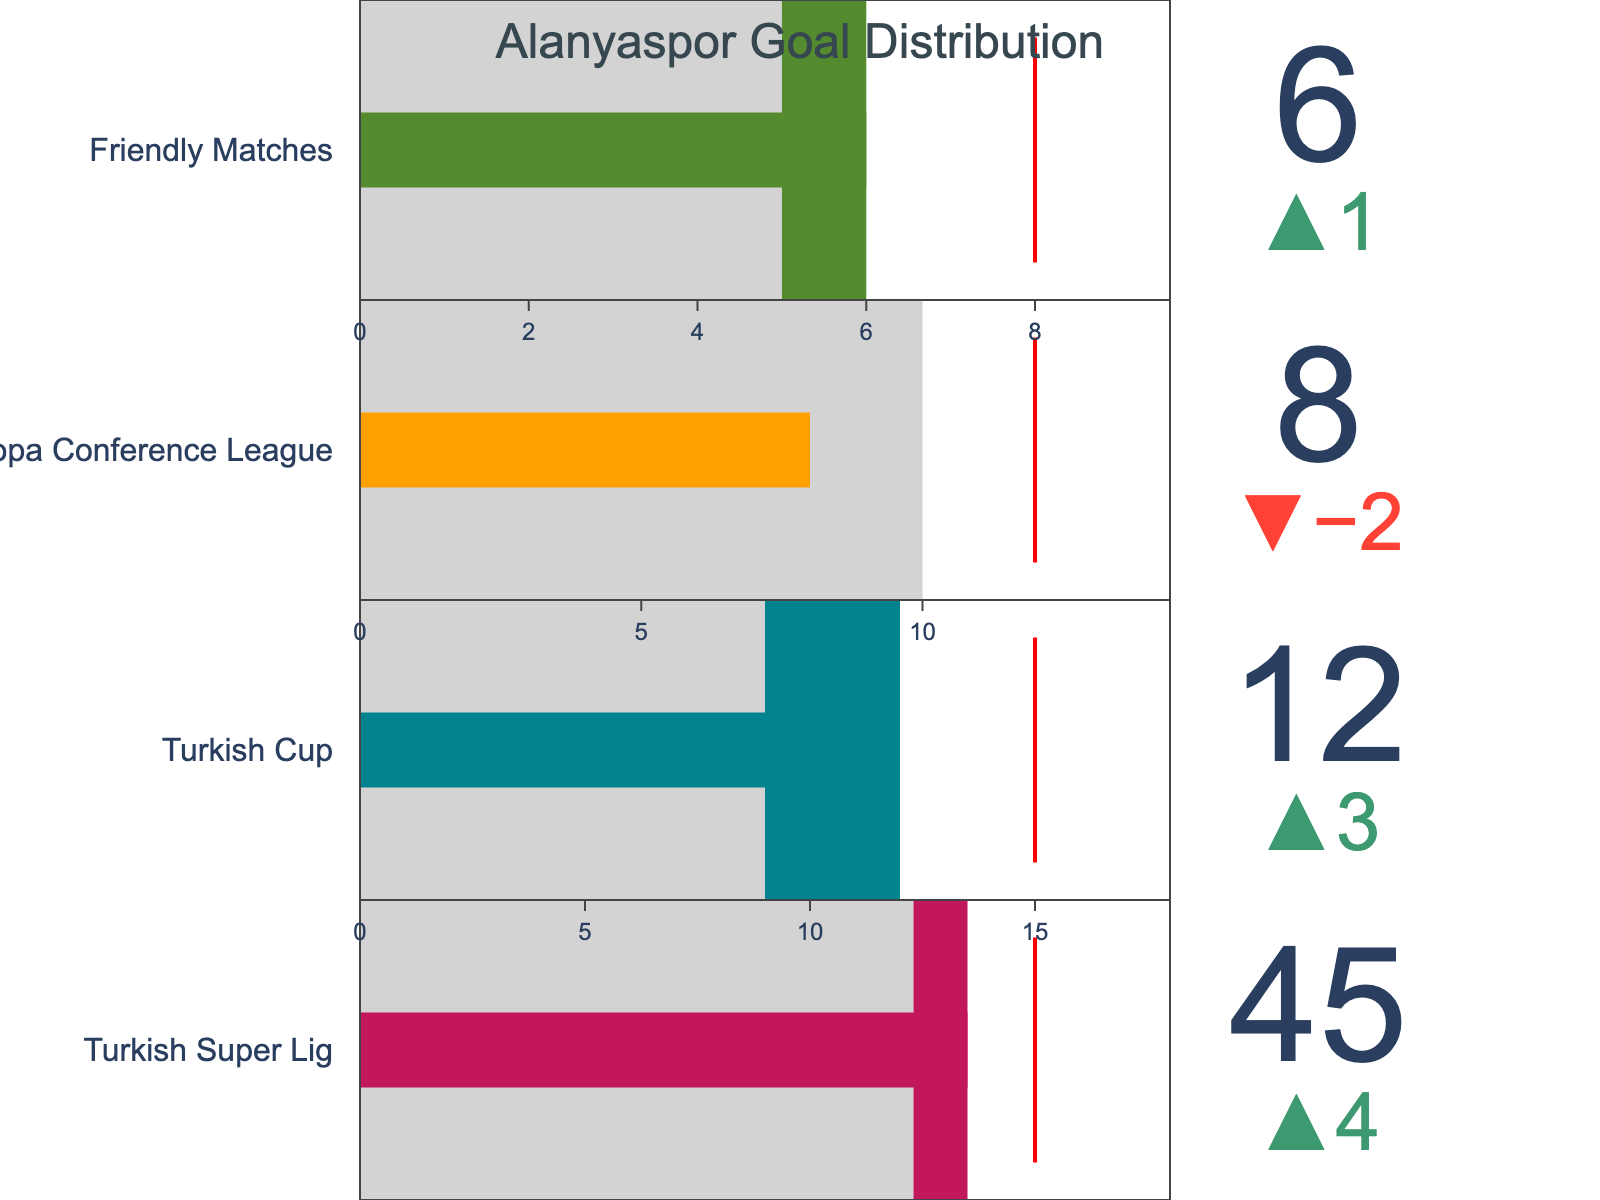What is the total number of goals scored by Alanyaspor in the Turkish Super Lig? The value indicating Alanyaspor Goals for the Turkish Super Lig is directly presented in the figure.
Answer: 45 How does Alanyaspor's goal count in the Turkish Cup compare to the League Average? Alanyaspor scored 12 goals in the Turkish Cup, while the League Average is 9 goals, showing that Alanyaspor scored 3 more than the average.
Answer: 3 more goals Which competition has the highest goal target for Alanyaspor? By comparing the Target values across all competitions, the Turkish Super Lig has the highest goal target, which is set at 50.
Answer: Turkish Super Lig What is the difference between Alanyaspor's goals and their target in UEFA Europa Conference League? Alanyaspor scored 8 goals, and the target was 12. The difference is calculated by subtracting 8 from 12.
Answer: 4 goals In which competition did Alanyaspor score almost the same number of goals as the League Average? Comparing Alanyaspor Goals to the League Average across all competitions, Friendly Matches show a close match, with 6 goals versus an average of 5.
Answer: Friendly Matches How does Alanyaspor's performance in the UEFA Europa Conference League compare to the Friendly Matches in terms of goals scored? Alanyaspor scored 8 goals in UEFA Europa Conference League and 6 goals in Friendly Matches, meaning they scored 2 more goals in the UEFA competition than in Friendly Matches.
Answer: 2 more goals What is the goal gap between Alanyaspor and the League Average in the Turkish Super Lig? Alanyaspor scored 45 goals, while the League Average is 41, giving a gap of 4 goals.
Answer: 4 goals Which competition shows the largest difference between Alanyaspor's goals and their target? By comparing the differences between goals and targets across all competitions (5, 3, 4, 2), the Turkish Super Lig shows the largest difference, with 5 goals short of the target of 50.
Answer: Turkish Super Lig 